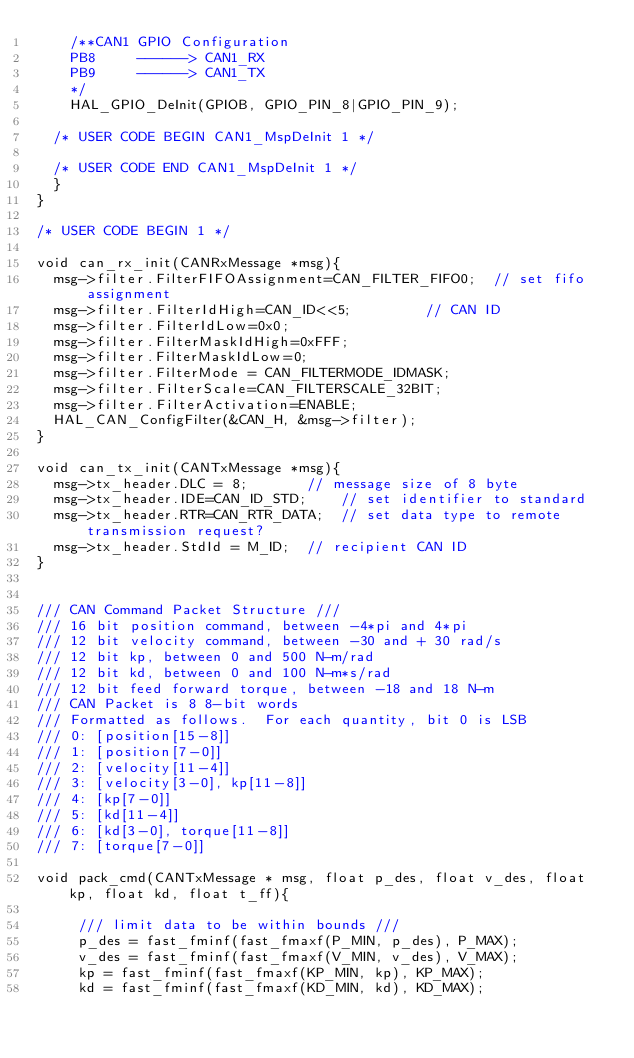Convert code to text. <code><loc_0><loc_0><loc_500><loc_500><_C_>    /**CAN1 GPIO Configuration
    PB8     ------> CAN1_RX
    PB9     ------> CAN1_TX
    */
    HAL_GPIO_DeInit(GPIOB, GPIO_PIN_8|GPIO_PIN_9);

  /* USER CODE BEGIN CAN1_MspDeInit 1 */

  /* USER CODE END CAN1_MspDeInit 1 */
  }
}

/* USER CODE BEGIN 1 */

void can_rx_init(CANRxMessage *msg){
	msg->filter.FilterFIFOAssignment=CAN_FILTER_FIFO0; 	// set fifo assignment
	msg->filter.FilterIdHigh=CAN_ID<<5; 				// CAN ID
	msg->filter.FilterIdLow=0x0;
	msg->filter.FilterMaskIdHigh=0xFFF;
	msg->filter.FilterMaskIdLow=0;
	msg->filter.FilterMode = CAN_FILTERMODE_IDMASK;
	msg->filter.FilterScale=CAN_FILTERSCALE_32BIT;
	msg->filter.FilterActivation=ENABLE;
	HAL_CAN_ConfigFilter(&CAN_H, &msg->filter);
}

void can_tx_init(CANTxMessage *msg){
	msg->tx_header.DLC = 8; 			// message size of 8 byte
	msg->tx_header.IDE=CAN_ID_STD; 		// set identifier to standard
	msg->tx_header.RTR=CAN_RTR_DATA; 	// set data type to remote transmission request?
	msg->tx_header.StdId = M_ID;  // recipient CAN ID
}


/// CAN Command Packet Structure ///
/// 16 bit position command, between -4*pi and 4*pi
/// 12 bit velocity command, between -30 and + 30 rad/s
/// 12 bit kp, between 0 and 500 N-m/rad
/// 12 bit kd, between 0 and 100 N-m*s/rad
/// 12 bit feed forward torque, between -18 and 18 N-m
/// CAN Packet is 8 8-bit words
/// Formatted as follows.  For each quantity, bit 0 is LSB
/// 0: [position[15-8]]
/// 1: [position[7-0]]
/// 2: [velocity[11-4]]
/// 3: [velocity[3-0], kp[11-8]]
/// 4: [kp[7-0]]
/// 5: [kd[11-4]]
/// 6: [kd[3-0], torque[11-8]]
/// 7: [torque[7-0]]

void pack_cmd(CANTxMessage * msg, float p_des, float v_des, float kp, float kd, float t_ff){

     /// limit data to be within bounds ///
     p_des = fast_fminf(fast_fmaxf(P_MIN, p_des), P_MAX);
     v_des = fast_fminf(fast_fmaxf(V_MIN, v_des), V_MAX);
     kp = fast_fminf(fast_fmaxf(KP_MIN, kp), KP_MAX);
     kd = fast_fminf(fast_fmaxf(KD_MIN, kd), KD_MAX);</code> 